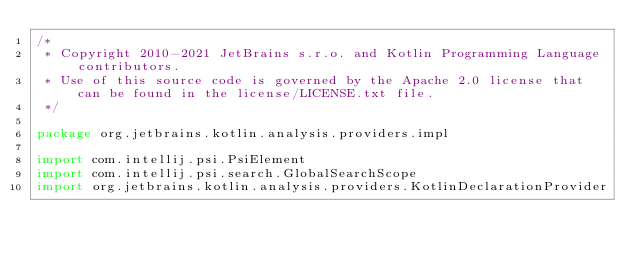Convert code to text. <code><loc_0><loc_0><loc_500><loc_500><_Kotlin_>/*
 * Copyright 2010-2021 JetBrains s.r.o. and Kotlin Programming Language contributors.
 * Use of this source code is governed by the Apache 2.0 license that can be found in the license/LICENSE.txt file.
 */

package org.jetbrains.kotlin.analysis.providers.impl

import com.intellij.psi.PsiElement
import com.intellij.psi.search.GlobalSearchScope
import org.jetbrains.kotlin.analysis.providers.KotlinDeclarationProvider</code> 